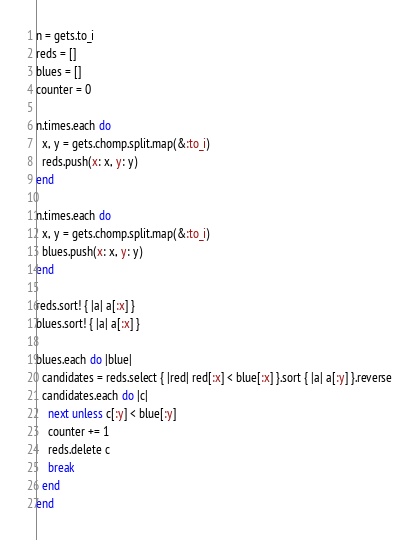<code> <loc_0><loc_0><loc_500><loc_500><_Ruby_>n = gets.to_i
reds = []
blues = []
counter = 0

n.times.each do
  x, y = gets.chomp.split.map(&:to_i)
  reds.push(x: x, y: y)
end

n.times.each do
  x, y = gets.chomp.split.map(&:to_i)
  blues.push(x: x, y: y)
end

reds.sort! { |a| a[:x] }
blues.sort! { |a| a[:x] }

blues.each do |blue|
  candidates = reds.select { |red| red[:x] < blue[:x] }.sort { |a| a[:y] }.reverse
  candidates.each do |c|
    next unless c[:y] < blue[:y]
    counter += 1
    reds.delete c
    break
  end
end</code> 